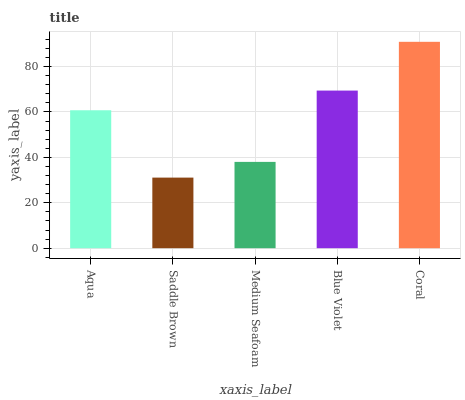Is Saddle Brown the minimum?
Answer yes or no. Yes. Is Coral the maximum?
Answer yes or no. Yes. Is Medium Seafoam the minimum?
Answer yes or no. No. Is Medium Seafoam the maximum?
Answer yes or no. No. Is Medium Seafoam greater than Saddle Brown?
Answer yes or no. Yes. Is Saddle Brown less than Medium Seafoam?
Answer yes or no. Yes. Is Saddle Brown greater than Medium Seafoam?
Answer yes or no. No. Is Medium Seafoam less than Saddle Brown?
Answer yes or no. No. Is Aqua the high median?
Answer yes or no. Yes. Is Aqua the low median?
Answer yes or no. Yes. Is Blue Violet the high median?
Answer yes or no. No. Is Blue Violet the low median?
Answer yes or no. No. 